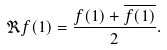Convert formula to latex. <formula><loc_0><loc_0><loc_500><loc_500>\Re f ( 1 ) = \frac { f ( 1 ) + \overline { f ( 1 ) } } { 2 } .</formula> 